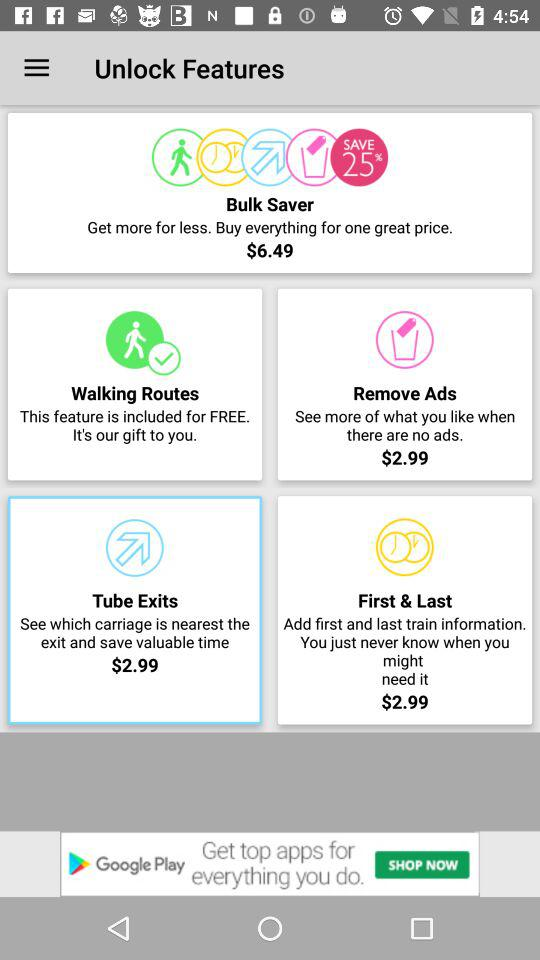What is the price of a "Bulk Saver"? The price is $6.49. 